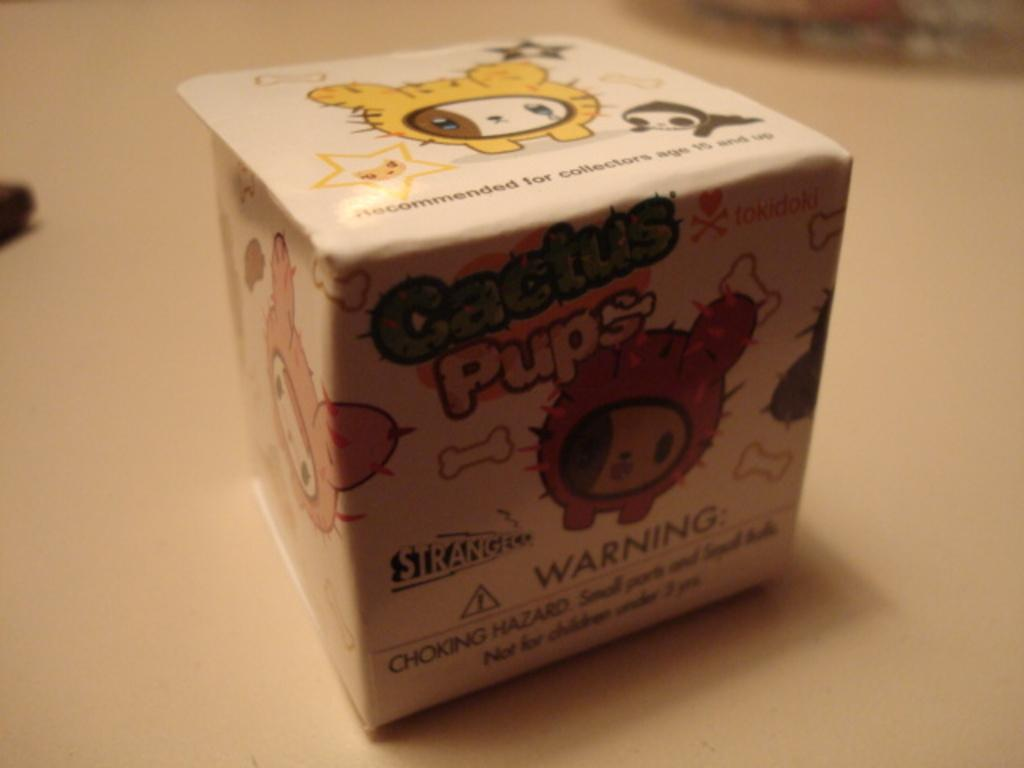<image>
Present a compact description of the photo's key features. a box that is labeled as cactus pups that has a warning label at the bottom of it 